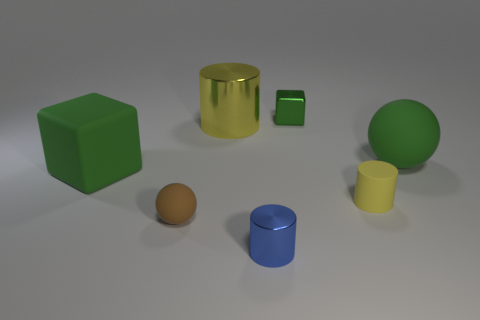What size is the sphere that is the same color as the matte cube?
Provide a succinct answer. Large. What is the shape of the metallic object behind the large metallic cylinder?
Ensure brevity in your answer.  Cube. Are there more rubber things that are to the right of the tiny yellow thing than big gray shiny objects?
Give a very brief answer. Yes. There is a yellow thing that is on the left side of the shiny cylinder that is in front of the brown object; how many small matte spheres are right of it?
Provide a short and direct response. 0. Do the yellow cylinder to the right of the tiny green object and the blue object that is in front of the matte cube have the same size?
Provide a succinct answer. Yes. What is the material of the yellow cylinder behind the big green rubber thing to the right of the blue thing?
Provide a succinct answer. Metal. What number of things are either green cubes that are left of the small brown ball or large matte objects?
Provide a short and direct response. 2. Is the number of big yellow objects that are to the left of the big green cube the same as the number of metal things that are behind the small block?
Offer a very short reply. Yes. There is a green block that is on the left side of the metal cylinder in front of the big green matte object that is left of the small yellow rubber cylinder; what is its material?
Offer a very short reply. Rubber. How big is the object that is both left of the tiny blue thing and in front of the tiny yellow matte cylinder?
Your answer should be very brief. Small. 